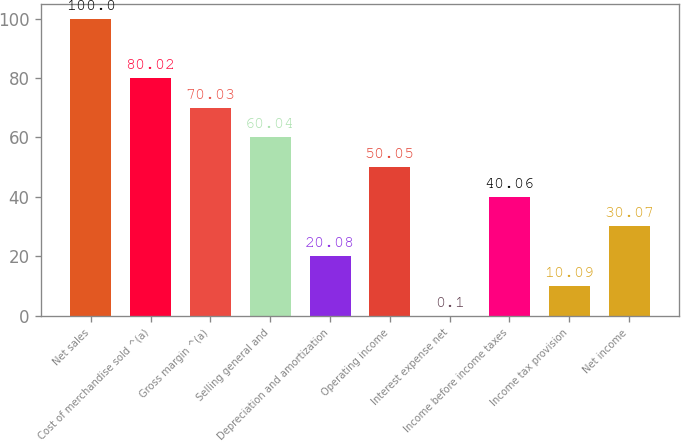<chart> <loc_0><loc_0><loc_500><loc_500><bar_chart><fcel>Net sales<fcel>Cost of merchandise sold ^(a)<fcel>Gross margin ^(a)<fcel>Selling general and<fcel>Depreciation and amortization<fcel>Operating income<fcel>Interest expense net<fcel>Income before income taxes<fcel>Income tax provision<fcel>Net income<nl><fcel>100<fcel>80.02<fcel>70.03<fcel>60.04<fcel>20.08<fcel>50.05<fcel>0.1<fcel>40.06<fcel>10.09<fcel>30.07<nl></chart> 